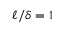Convert formula to latex. <formula><loc_0><loc_0><loc_500><loc_500>\ell / \delta = 1</formula> 